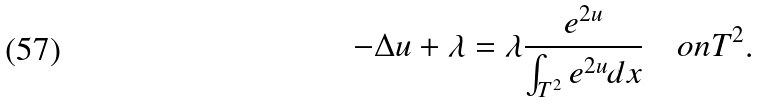Convert formula to latex. <formula><loc_0><loc_0><loc_500><loc_500>- \Delta u + \lambda = \lambda \frac { e ^ { 2 u } } { \int _ { T ^ { 2 } } e ^ { 2 u } d x } \quad o n T ^ { 2 } .</formula> 